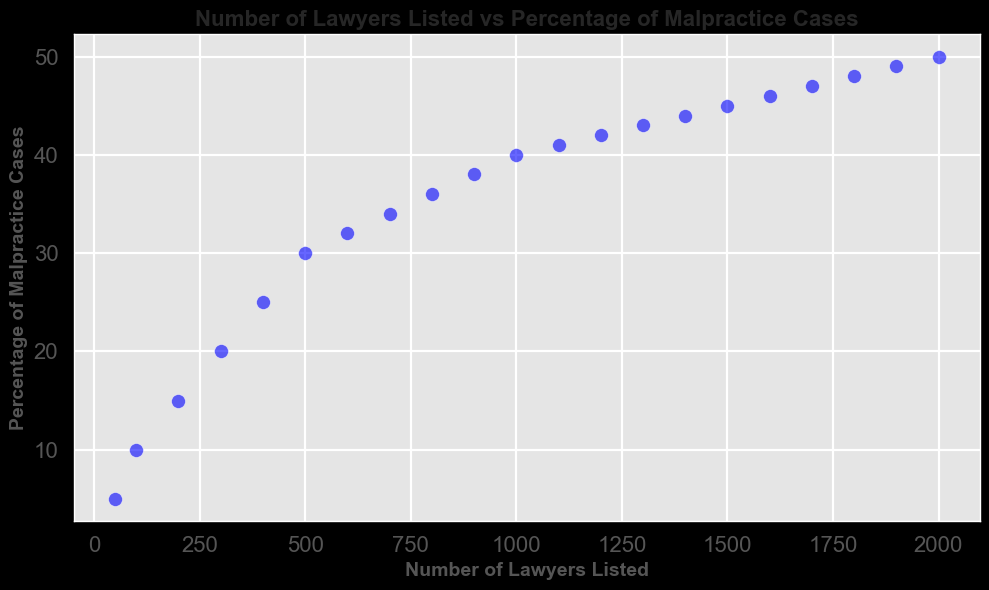How does the percentage of malpractice cases change as the number of lawyers listed in the directory increases from 50 to 1000? The figure shows a scatter plot with the number of lawyers listed on the x-axis and the percentage of malpractice cases on the y-axis. As the number of lawyers listed increases from 50 to 1000, the percentage of malpractice cases steadily rises from 5% to 40%.
Answer: It increases from 5% to 40% How many data points are shown in the scatter plot? The scatter plot represents data points corresponding to the pairs of values given. Counting the points, there are 21 pairs, hence 21 data points.
Answer: 21 What is the percentage increase in malpractice cases when the number of lawyers increases from 1000 to 2000? At 1000 lawyers, the percentage of malpractice cases is 40%. At 2000 lawyers, it is 50%. The percentage increase is calculated as (50 - 40) / 40 * 100 = 25%.
Answer: 25% Which specific number of lawyers listed is associated with the steepest increase in malpractice percentages, and what is that increase? The visual spacing between data points can point to the steepest rise. From 500 to 600 lawyers, the percentage of malpractice cases increases by 2% (from 30% to 32%), which appears to be one of the steeper increments, though other intervals also have significant increases.
Answer: 100 lawyers, 2% increase What is the difference in the percentage of malpractice cases between 800 and 1200 lawyers listed? For 800 lawyers, the percentage is 36%. For 1200 lawyers, it is 42%. The difference is 42% - 36% = 6%.
Answer: 6% Is there any point where the increase in malpractice percentages starts to slow down? Visually, the plot suggests that around 1100 lawyers, the incremental increase in malpractice percentage becomes more gradual, shown by the smaller vertical gaps between points from 1100 to 2000 lawyers.
Answer: Around 1100 lawyers Among the points plotted, which has the highest percentage of malpractice cases and what is the corresponding number of lawyers listed? The point with the highest percentage of malpractice cases has 50% with 2000 lawyers listed. This is the topmost point in the scatter plot.
Answer: 2000 lawyers, 50% What are the percentage malpractice cases for the lowest and highest number of lawyers listed? The scatter plot shows that the lowest number of lawyers listed is 50 with 5% malpractice cases, and the highest number of lawyers listed is 2000 with 50% malpractice cases.
Answer: 5% and 50% Which data points show malpractice percentages above 40%? Points above 40% include 1100 (41%), 1200 (42%), 1300 (43%), 1400 (44%), 1500 (45%), 1600 (46%), 1700 (47%), 1800 (48%), 1900 (49%), and 2000 (50%). This can be visually confirmed by looking at the points above the 40% mark on the y-axis.
Answer: 1100 to 2000 lawyers 